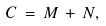<formula> <loc_0><loc_0><loc_500><loc_500>C \, = \, M \, + \, N ,</formula> 